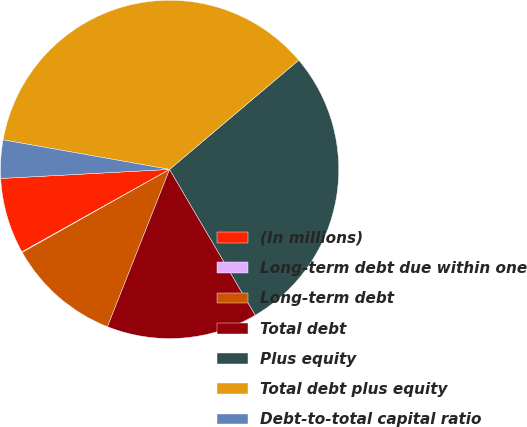Convert chart. <chart><loc_0><loc_0><loc_500><loc_500><pie_chart><fcel>(In millions)<fcel>Long-term debt due within one<fcel>Long-term debt<fcel>Total debt<fcel>Plus equity<fcel>Total debt plus equity<fcel>Debt-to-total capital ratio<nl><fcel>7.25%<fcel>0.06%<fcel>10.85%<fcel>14.44%<fcel>27.72%<fcel>36.03%<fcel>3.65%<nl></chart> 